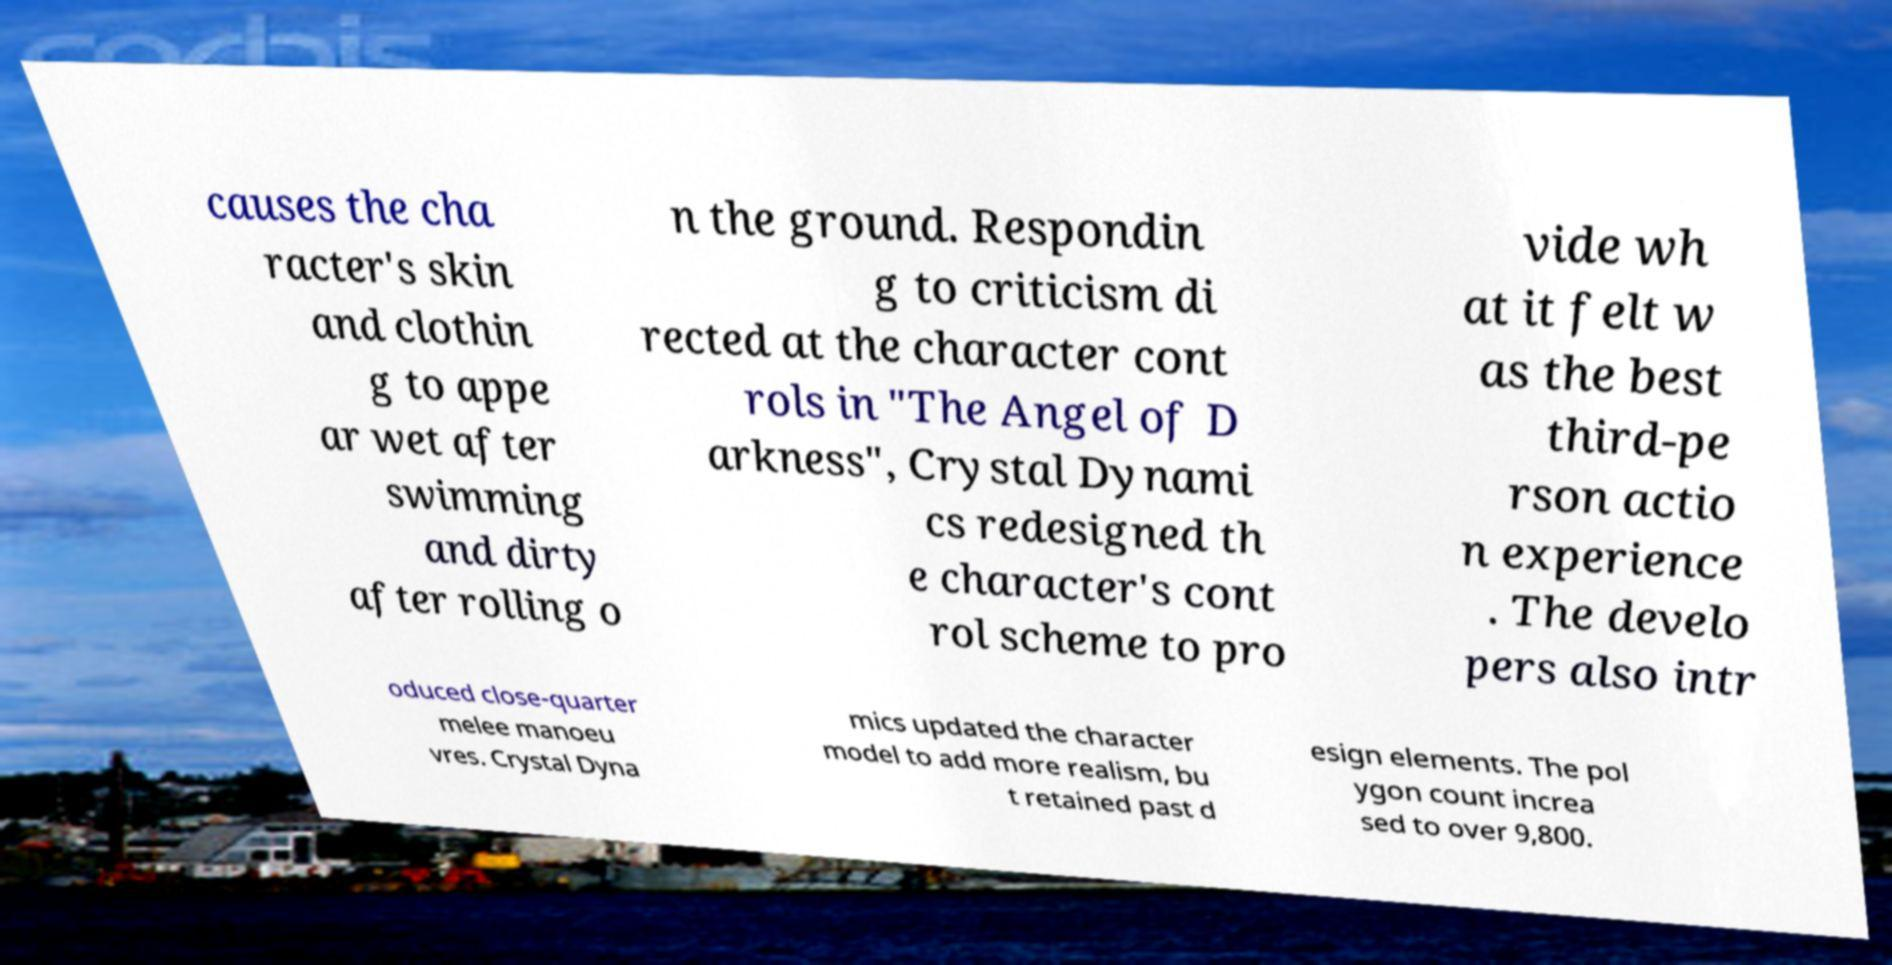There's text embedded in this image that I need extracted. Can you transcribe it verbatim? causes the cha racter's skin and clothin g to appe ar wet after swimming and dirty after rolling o n the ground. Respondin g to criticism di rected at the character cont rols in "The Angel of D arkness", Crystal Dynami cs redesigned th e character's cont rol scheme to pro vide wh at it felt w as the best third-pe rson actio n experience . The develo pers also intr oduced close-quarter melee manoeu vres. Crystal Dyna mics updated the character model to add more realism, bu t retained past d esign elements. The pol ygon count increa sed to over 9,800. 